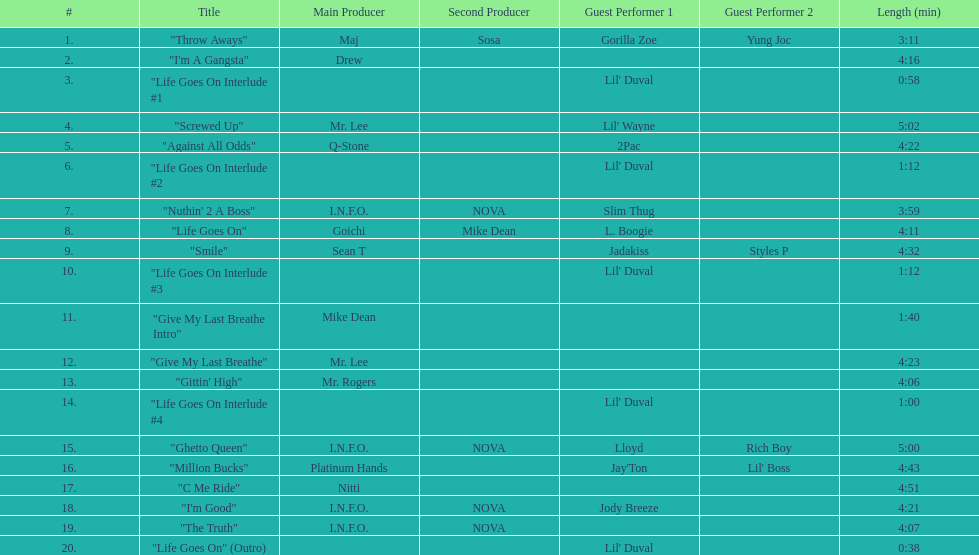What is the total number of tracks on the album? 20. 